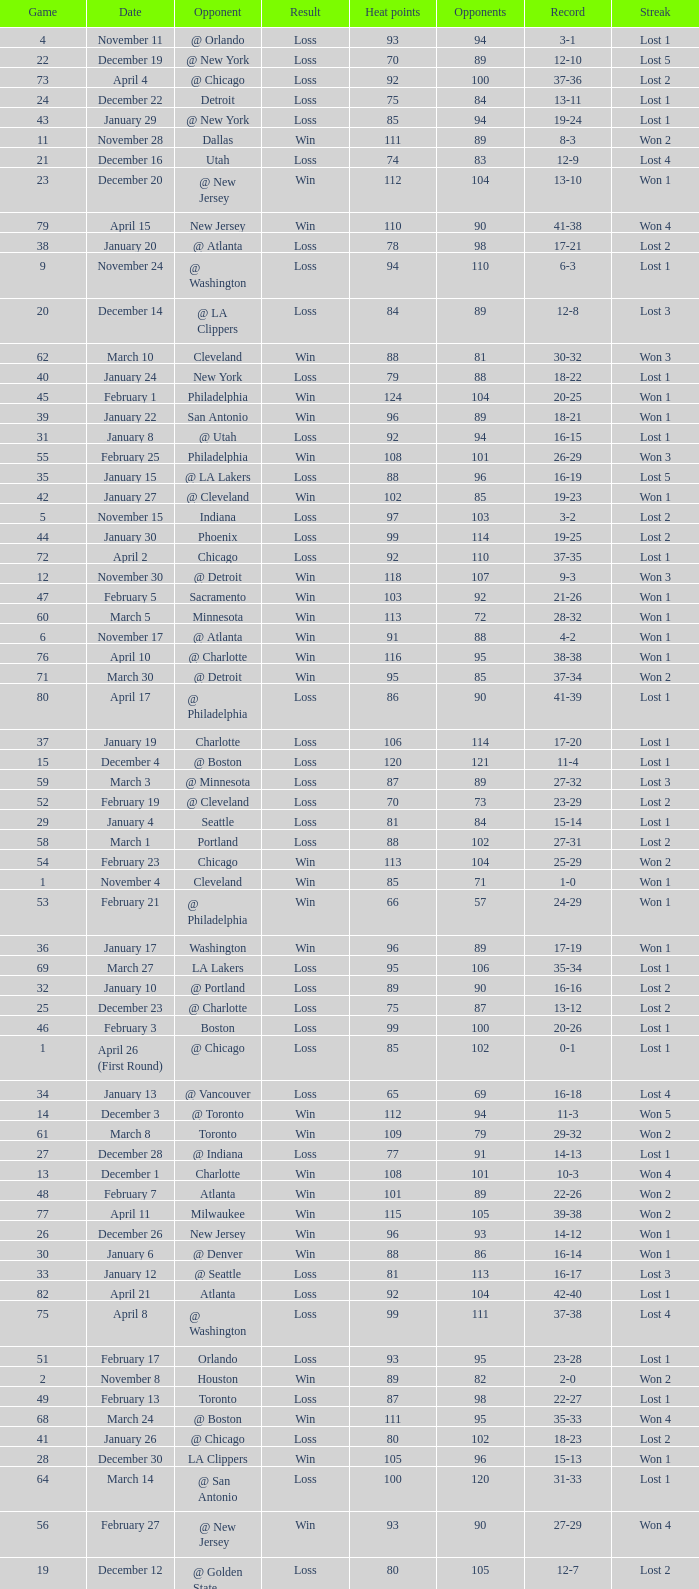What is Streak, when Heat Points is "101", and when Game is "16"? Lost 2. 